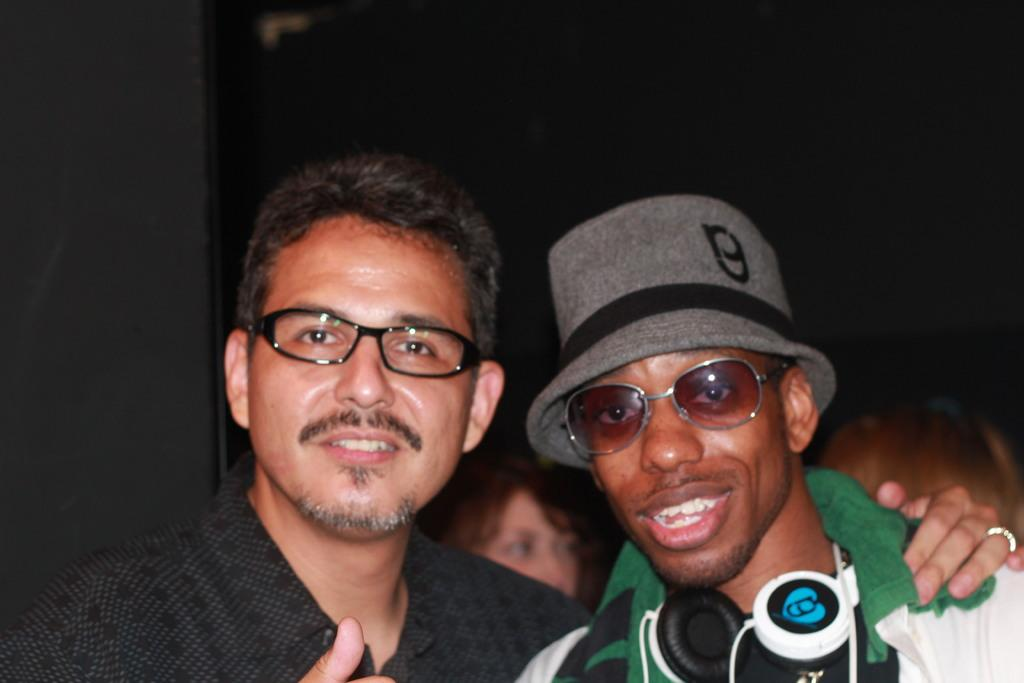How many people are in the foreground of the image? There are two men in the foreground of the image. What are the two men in the foreground doing? The two men are posing for a camera. How many people are visible in the background of the image? There are two people visible in the background of the image. Can you describe the lighting conditions in the image? The background appears to be dark. What riddle is being solved by the two men in the image? There is no riddle being solved in the image; the two men are posing for a camera. What songs are being sung by the people in the background of the image? There is no indication of any songs being sung in the image; the people in the background are not performing any activities. 